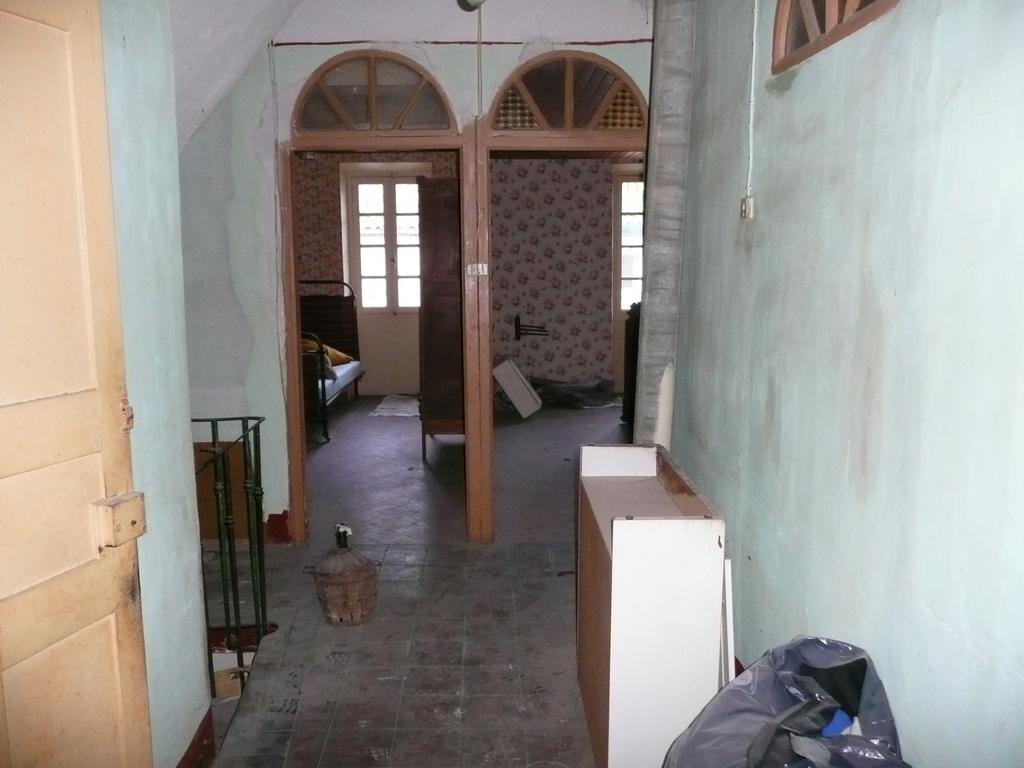What type of space is depicted in the image? The image shows an inner view of a room. How many windows are present in the room? There are four windows in the room. What piece of furniture can be seen in the room? There is a bed in the room. Is there a way to enter or exit the room? Yes, there is a door in the room. What can be found on the floor of the room? There are objects on the floor. What is located on the right side of the room? There is a wall and a wooden object on the right side of the room. How does the pollution affect the room in the image? There is no mention of pollution in the image, so it cannot be determined how it affects the room. 